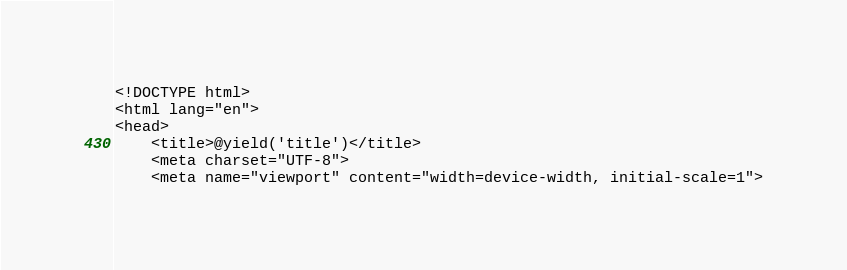<code> <loc_0><loc_0><loc_500><loc_500><_PHP_><!DOCTYPE html>
<html lang="en">
<head>
    <title>@yield('title')</title>
    <meta charset="UTF-8">
    <meta name="viewport" content="width=device-width, initial-scale=1"></code> 